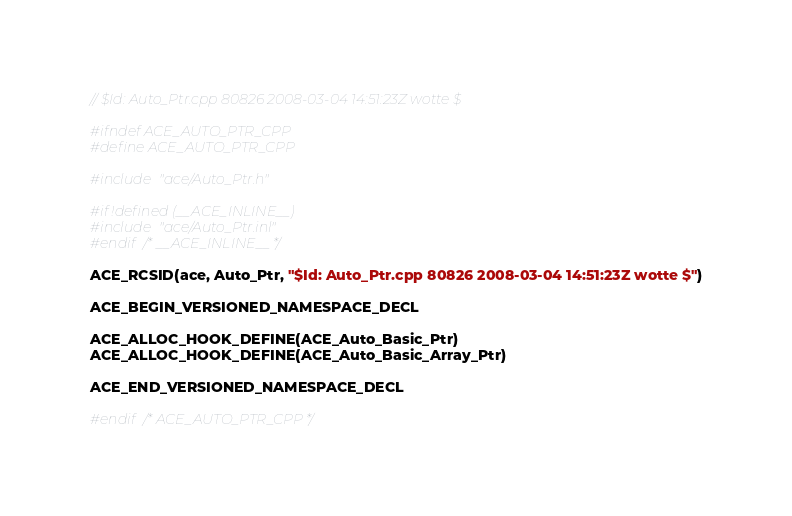<code> <loc_0><loc_0><loc_500><loc_500><_C++_>// $Id: Auto_Ptr.cpp 80826 2008-03-04 14:51:23Z wotte $

#ifndef ACE_AUTO_PTR_CPP
#define ACE_AUTO_PTR_CPP

#include "ace/Auto_Ptr.h"

#if !defined (__ACE_INLINE__)
#include "ace/Auto_Ptr.inl"
#endif /* __ACE_INLINE__ */

ACE_RCSID(ace, Auto_Ptr, "$Id: Auto_Ptr.cpp 80826 2008-03-04 14:51:23Z wotte $")

ACE_BEGIN_VERSIONED_NAMESPACE_DECL

ACE_ALLOC_HOOK_DEFINE(ACE_Auto_Basic_Ptr)
ACE_ALLOC_HOOK_DEFINE(ACE_Auto_Basic_Array_Ptr)

ACE_END_VERSIONED_NAMESPACE_DECL

#endif /* ACE_AUTO_PTR_CPP */
</code> 